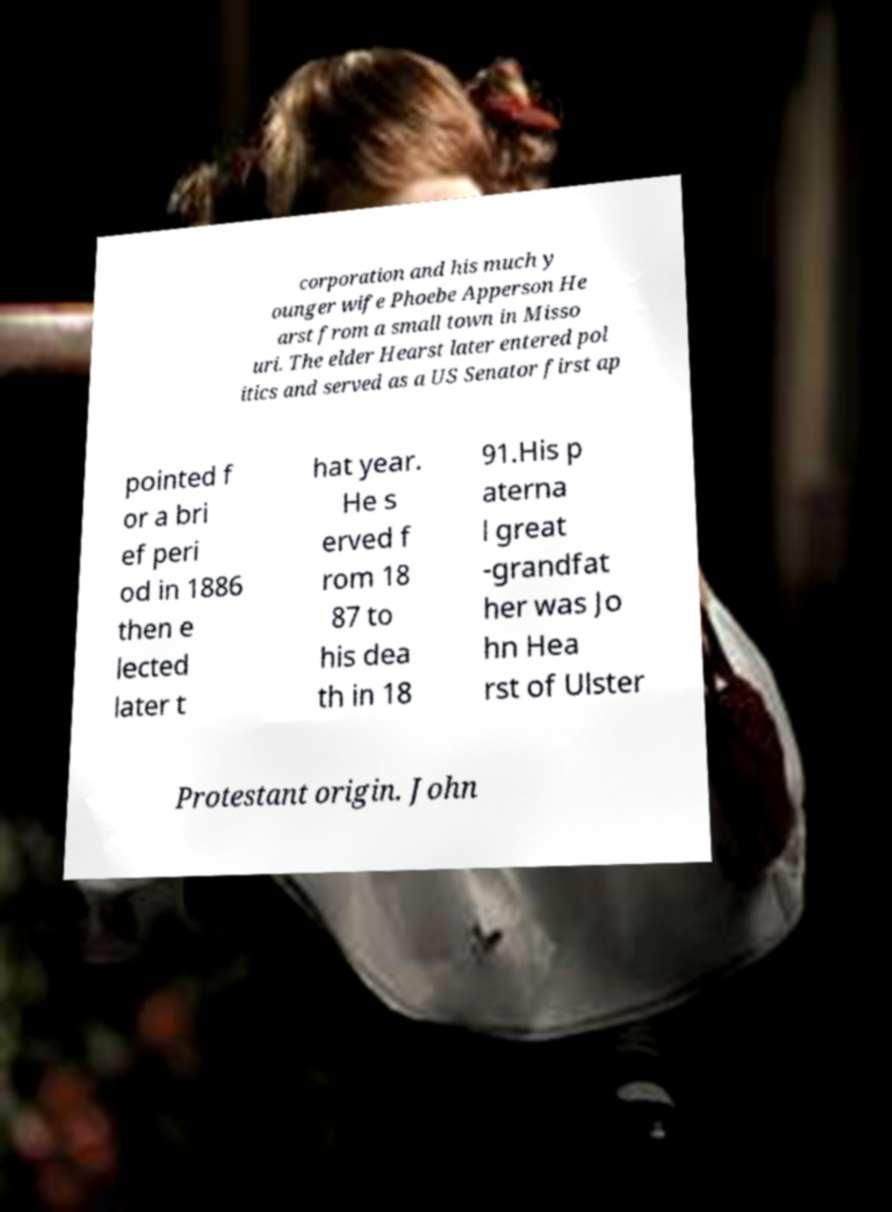Could you assist in decoding the text presented in this image and type it out clearly? corporation and his much y ounger wife Phoebe Apperson He arst from a small town in Misso uri. The elder Hearst later entered pol itics and served as a US Senator first ap pointed f or a bri ef peri od in 1886 then e lected later t hat year. He s erved f rom 18 87 to his dea th in 18 91.His p aterna l great -grandfat her was Jo hn Hea rst of Ulster Protestant origin. John 